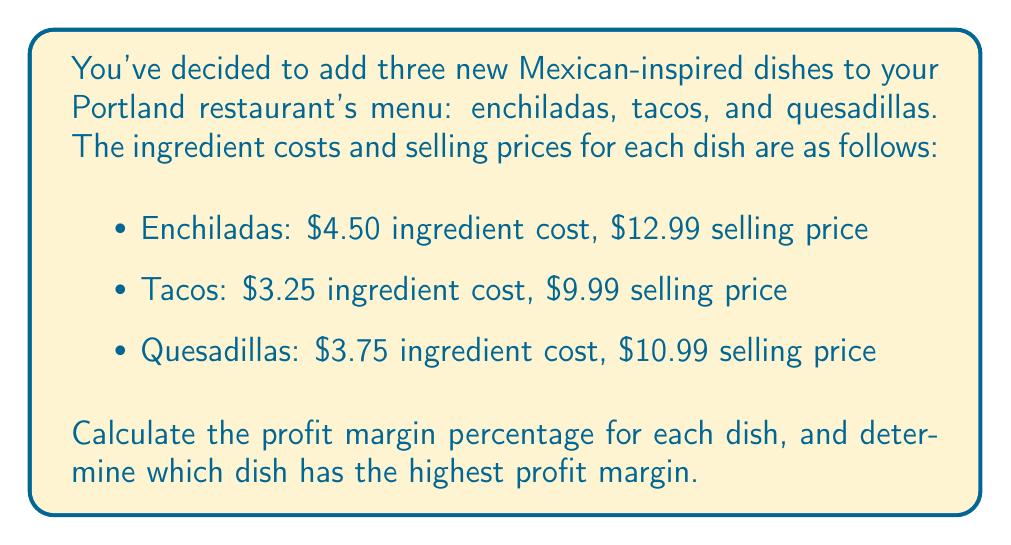Teach me how to tackle this problem. To calculate the profit margin percentage for each dish, we'll use the following formula:

$$\text{Profit Margin} \% = \frac{\text{Selling Price} - \text{Ingredient Cost}}{\text{Selling Price}} \times 100\%$$

Let's calculate for each dish:

1. Enchiladas:
   $$\text{Profit Margin} \% = \frac{\$12.99 - \$4.50}{\$12.99} \times 100\% = \frac{\$8.49}{\$12.99} \times 100\% \approx 65.36\%$$

2. Tacos:
   $$\text{Profit Margin} \% = \frac{\$9.99 - \$3.25}{\$9.99} \times 100\% = \frac{\$6.74}{\$9.99} \times 100\% \approx 67.47\%$$

3. Quesadillas:
   $$\text{Profit Margin} \% = \frac{\$10.99 - \$3.75}{\$10.99} \times 100\% = \frac{\$7.24}{\$10.99} \times 100\% \approx 65.88\%$$

Comparing the profit margins:
- Enchiladas: 65.36%
- Tacos: 67.47%
- Quesadillas: 65.88%

The dish with the highest profit margin is tacos at 67.47%.
Answer: Enchiladas: 65.36%
Tacos: 67.47%
Quesadillas: 65.88%

The dish with the highest profit margin is tacos at 67.47%. 